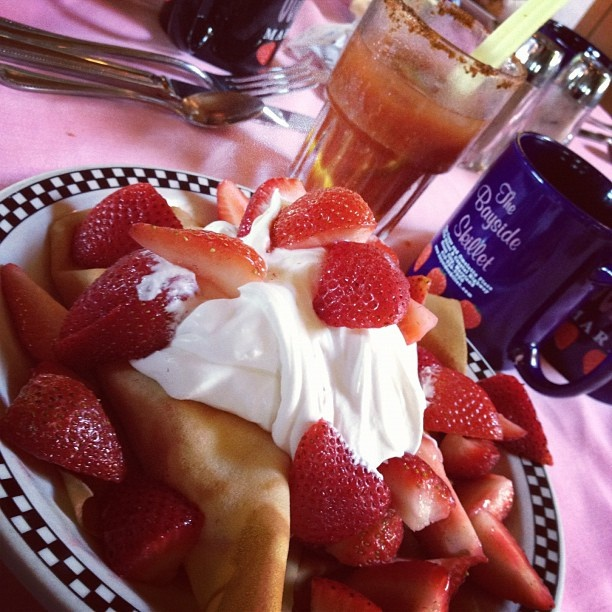Describe the objects in this image and their specific colors. I can see cup in violet, black, navy, and purple tones, dining table in violet, pink, lightpink, and brown tones, cup in violet, brown, and maroon tones, cup in violet, black, maroon, purple, and darkgray tones, and spoon in violet, maroon, and brown tones in this image. 